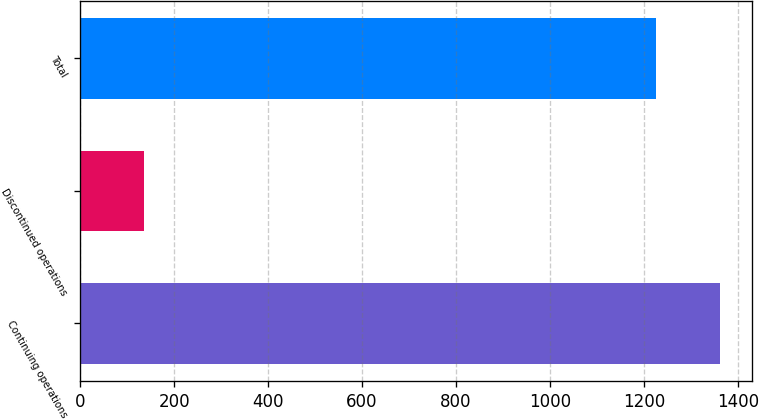Convert chart. <chart><loc_0><loc_0><loc_500><loc_500><bar_chart><fcel>Continuing operations<fcel>Discontinued operations<fcel>Total<nl><fcel>1362<fcel>136<fcel>1226<nl></chart> 